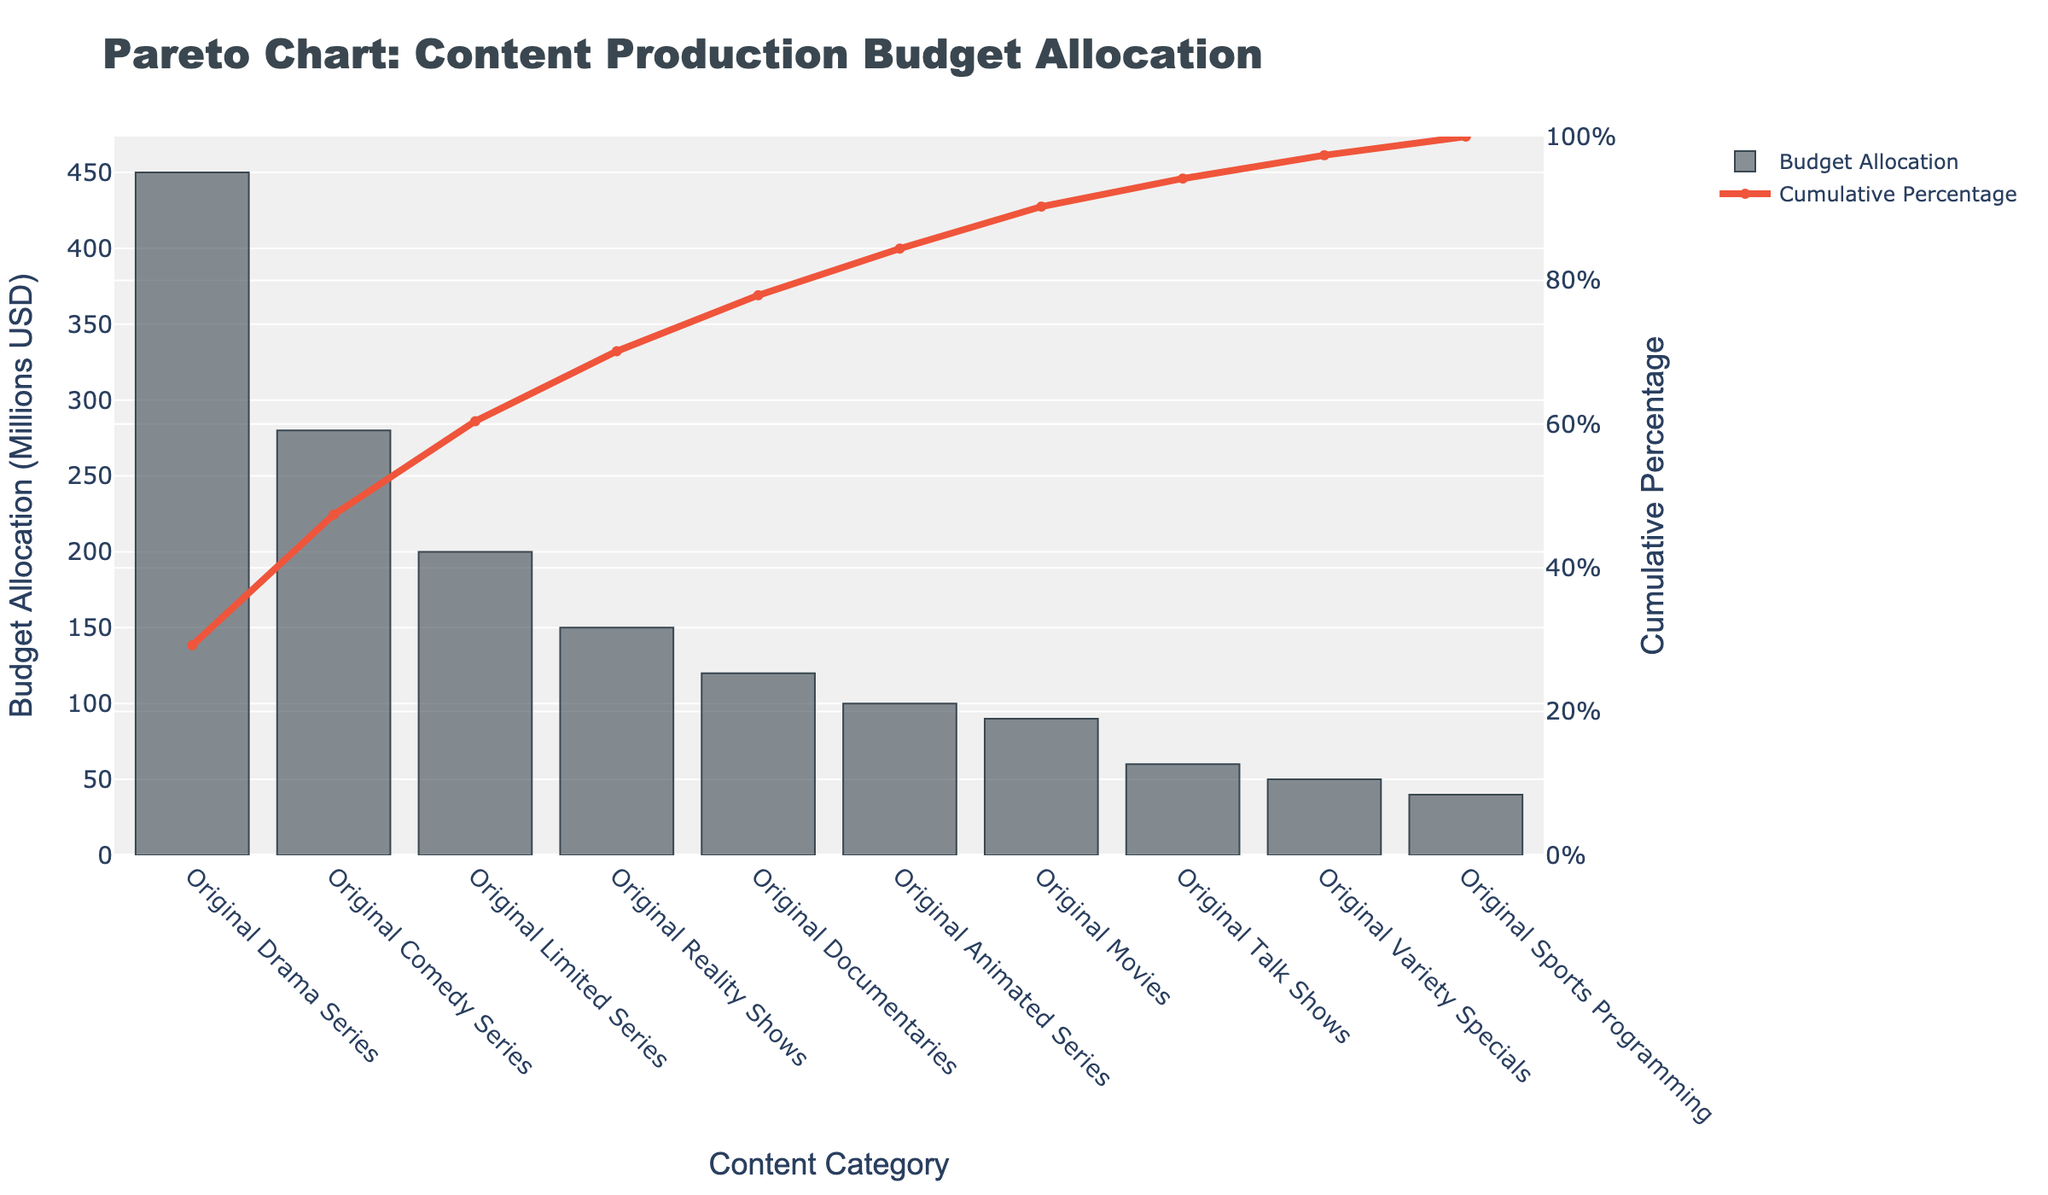What is the total budget allocated to the Original Drama Series? The bar chart shows that the budget allocation for the Original Drama Series is depicted with the highest bar, which is labeled 450 million USD.
Answer: 450 million USD What type of original programming has the second highest budget allocation? The second highest bar in the chart represents the Original Comedy Series, with a budget allocation of 280 million USD.
Answer: Original Comedy Series What cumulative percentage does the Original Comedy Series contribute to the overall budget? The line chart indicates the cumulative percentage and is directly above the bar for the Original Comedy Series. The cumulative percentage value shown is 62.3%.
Answer: 62.3% How much more budget is allocated to Original Drama Series compared to Original Movies? By observing the heights of the respective bars, Original Drama Series has been allocated 450 million USD and Original Movies 90 million USD. The difference is 450 - 90 = 360 million USD.
Answer: 360 million USD Which content category is associated with the steepest increase in cumulative percentage? The steepest increase in the line chart occurs between the Original Drama Series and Original Comedy Series, indicating that these categories contributed significantly to the cumulative percentage.
Answer: Between Drama Series and Comedy Series What percentage of the budget is allocated to categories listed under Original Reality Shows and below? The categories from Original Reality Shows and below are summed (150 + 120 + 100 + 90 + 60 + 50 + 40 = 610 million USD). To find the percentage, divide by the total (610 / 1540) and multiply by 100, giving approximately 39.6%.
Answer: 39.6% Which content category has the smallest budget allocation? The smallest bar in the chart represents Original Sports Programming, with a budget of 40 million USD.
Answer: Original Sports Programming Which content categories collectively make up around 50% of the total budget? The bars for Original Drama Series and Original Comedy Series represent budgets of 450 million USD and 280 million USD respectively. Adding them, 450 + 280 = 730 million USD, which is approximately 47.4% of the total budget. Include Original Limited Series (200 million USD), totaling 930 million USD, which is around 60.4%. To be precise around 50%, it is just Drama Series and Comedy Series.
Answer: Original Drama Series and Original Comedy Series How many categories' budget allocations add up to more than 75% of the total budget? Observing the cumulative percentage line chart, more than 75% is reached by summing the first four categories: Original Drama Series (450), Original Comedy Series (280), Original Limited Series (200), and Original Reality Shows (150). Adding them up yields a cumulative 1080 million USD, which is approximately 70.1%. Including Original Documentaries (120), totaling 1200 million USD, which is around 77.9%. Therefore, it is the first five categories.
Answer: Five categories 